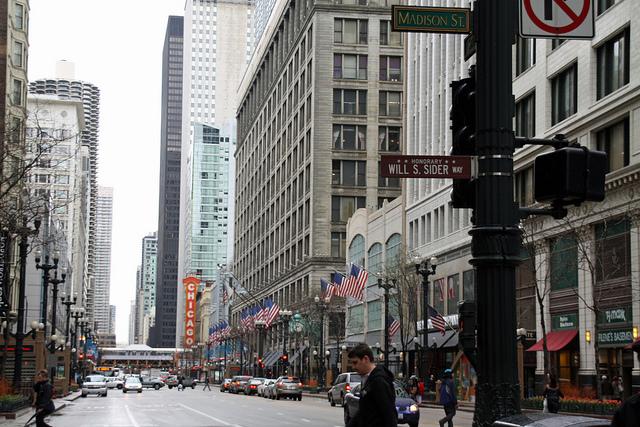What is the name of the street?
Answer briefly. Will s sider. What street name is visible?
Short answer required. Will s sider way. Are the street lights on?
Keep it brief. No. Is this a small neighborhood?
Write a very short answer. No. What color are the poles holding up the traffic signals?
Keep it brief. Black. Are all the street lights on?
Give a very brief answer. No. Why are there two lights?
Concise answer only. Unknown. On what continent is the woman standing?
Quick response, please. North america. What color is his jacket?
Quick response, please. Black. What flag is present in the photo?
Quick response, please. Usa. 